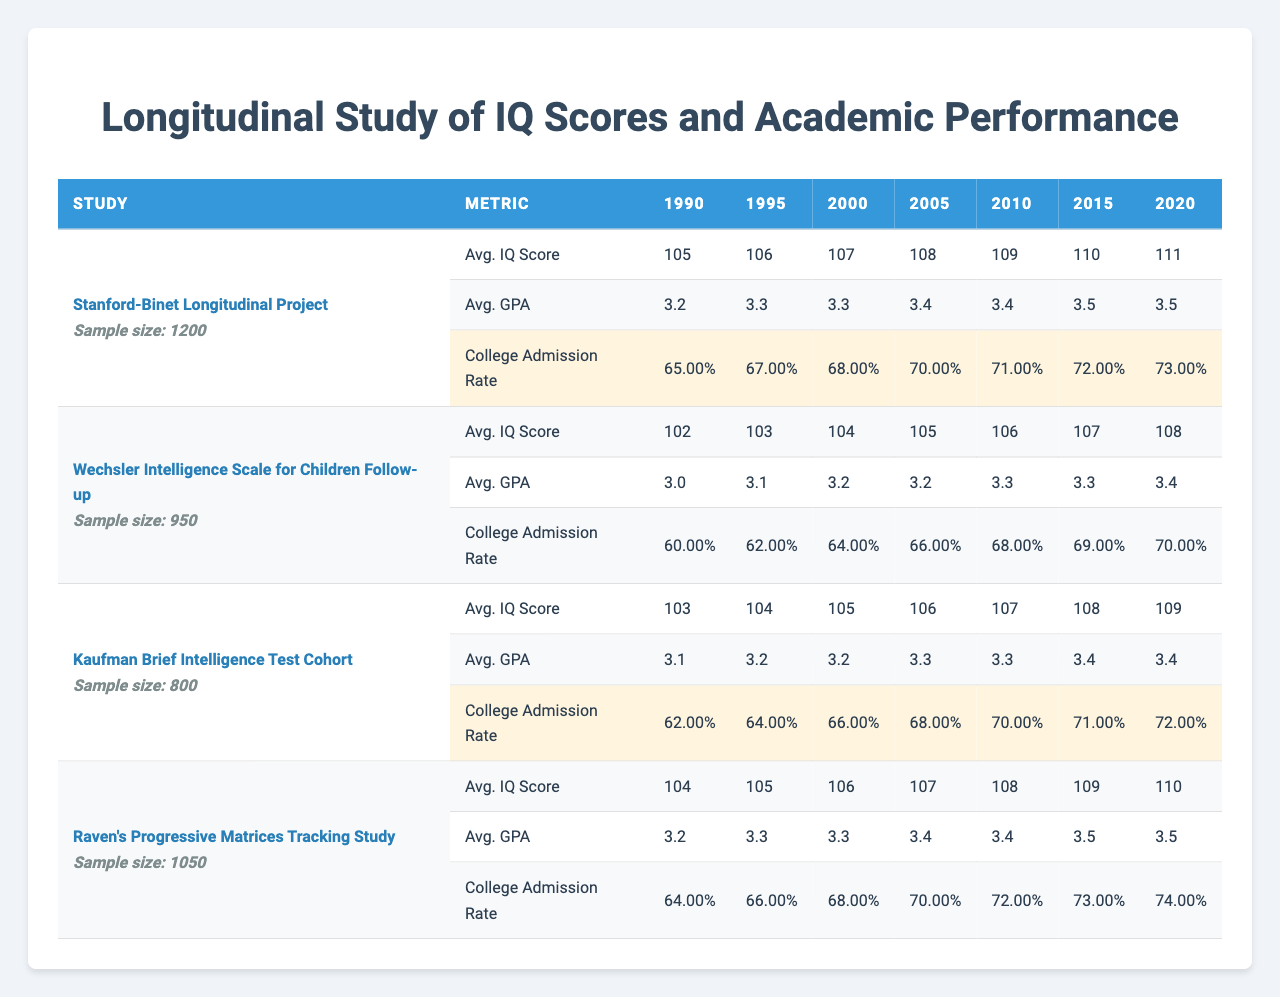What was the average IQ score in 2010 for the Stanford-Binet Longitudinal Project? According to the data, the average IQ score for the Stanford-Binet Longitudinal Project in 2010 is listed directly in the table, which shows a value of 109.
Answer: 109 Which study had the lowest average GPA in 1995? In the table, looking at the average GPA for 1995, the Wechsler Intelligence Scale for Children Follow-up has an average GPA of 3.1, which is the lowest compared to the other studies listed.
Answer: Wechsler Intelligence Scale for Children Follow-up What was the increase in college admission rate from 1990 to 2020 for the Raven's Progressive Matrices Tracking Study? The college admission rate for Raven’s Progressive Matrices Tracking Study in 1990 is 0.64 and in 2020 is 0.74. The increase is calculated as 0.74 - 0.64 = 0.10.
Answer: 0.10 Which study showed the most significant increase in average IQ score from 2000 to 2005? The average IQ scores for the studies from 2000 to 2005 are: Stanford-Binet (108 to 109), Wechsler (104 to 105), Kaufman (105 to 106), and Raven's (106 to 107). The Kaufman Brief Intelligence Test experienced an increase of 1 point, which is the highest among them.
Answer: Kaufman Brief Intelligence Test True or False: The average GPA for the Kaufman Brief Intelligence Test Cohort in 2015 was lower than that for Raven's Progressive Matrices Tracking Study in the same year. The average GPA for Kaufman in 2015 is 3.4, while for Raven's in 2015 it is also 3.5. Since 3.4 is lower than 3.5, the statement is true.
Answer: True What is the average college admission rate across all studies in 2020? The college admission rates for all studies in 2020 are: 0.73 (Stanford-Binet), 0.70 (Wechsler), 0.72 (Kaufman), 0.74 (Raven's). To find the average, sum these values: 0.73 + 0.70 + 0.72 + 0.74 = 2.89 and then divide by 4, yielding 0.7225.
Answer: 0.7225 Which study had the largest sample size? By comparing the sample sizes of all studies, the Stanford-Binet Longitudinal Project has the largest sample size of 1200, which is greater than the others listed.
Answer: Stanford-Binet Longitudinal Project What trend can be observed in the average IQ score from 1990 to 2020 for the Wechsler Intelligence Scale for Children Follow-up? The average IQ score for the Wechsler study increased from 102 in 1990 to 108 in 2020, showing a gradual upward trend over the 30 years.
Answer: Gradual upward trend Which year saw the highest average GPA across all studies? From the average GPAs listed by year, the highest value is seen in 2015 for both the Stanford-Binet and Raven's at 3.5, indicating that it is the highest year for average GPA.
Answer: 2015 How much did the average IQ score for the Stanford-Binet Longitudinal Project increase from 1990 to 2020? The average IQ score for Stanford-Binet increased from 105 in 1990 to 111 in 2020, resulting in an increase of 6 points calculated as 111 - 105.
Answer: 6 points 